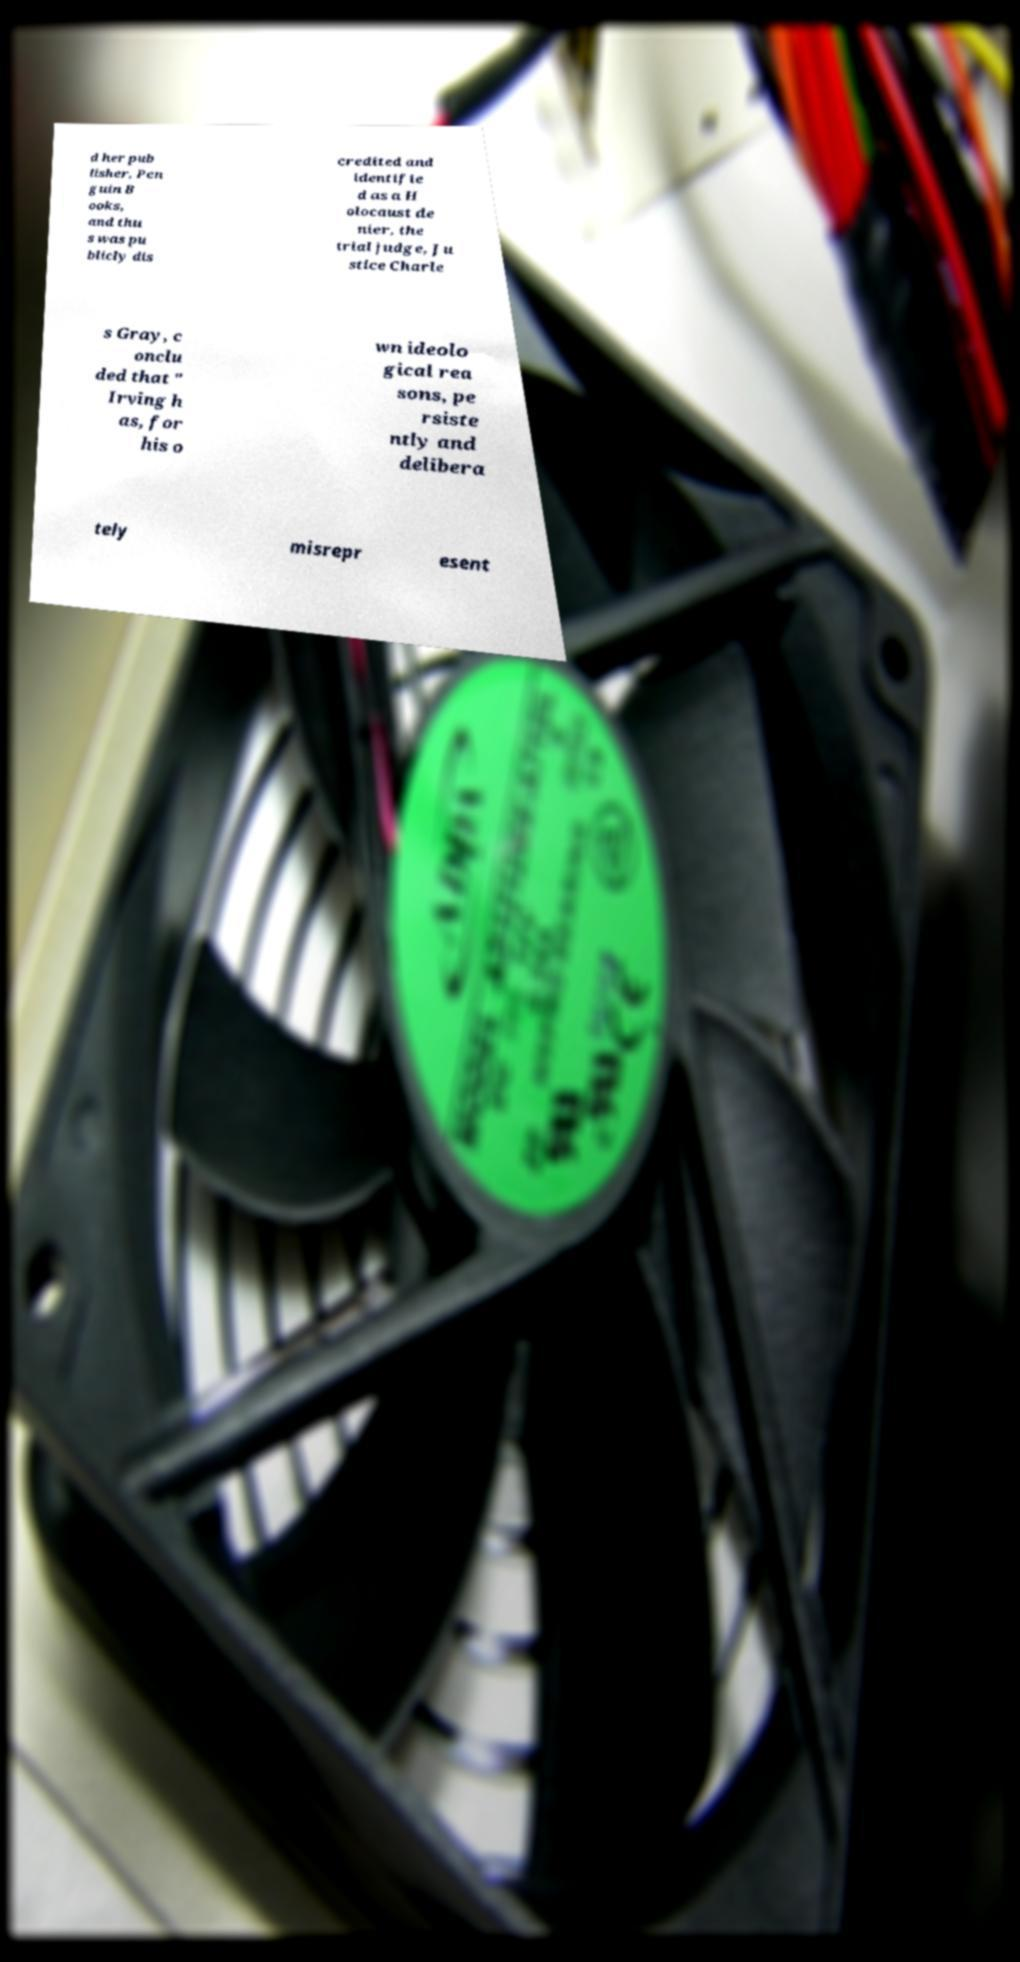There's text embedded in this image that I need extracted. Can you transcribe it verbatim? d her pub lisher, Pen guin B ooks, and thu s was pu blicly dis credited and identifie d as a H olocaust de nier, the trial judge, Ju stice Charle s Gray, c onclu ded that " Irving h as, for his o wn ideolo gical rea sons, pe rsiste ntly and delibera tely misrepr esent 